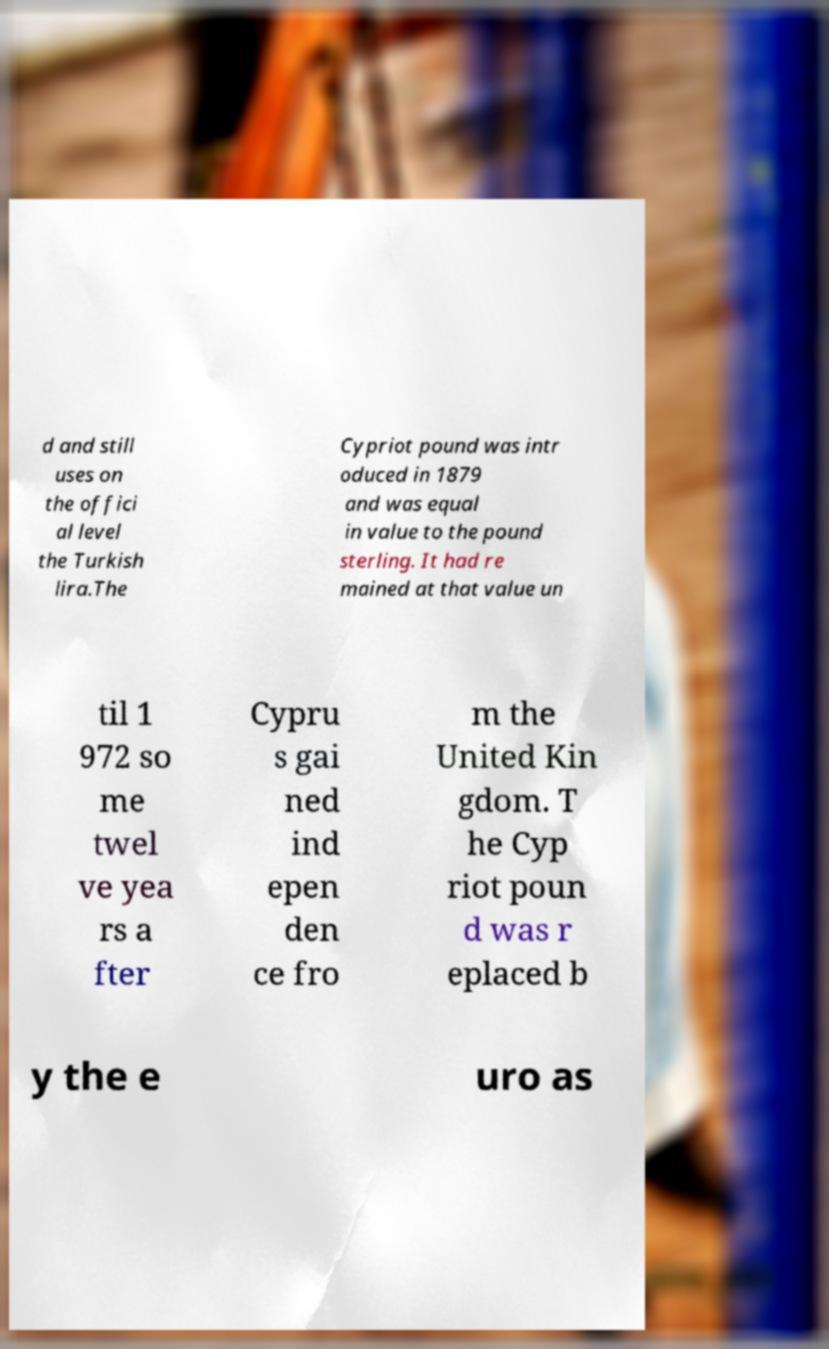What messages or text are displayed in this image? I need them in a readable, typed format. d and still uses on the offici al level the Turkish lira.The Cypriot pound was intr oduced in 1879 and was equal in value to the pound sterling. It had re mained at that value un til 1 972 so me twel ve yea rs a fter Cypru s gai ned ind epen den ce fro m the United Kin gdom. T he Cyp riot poun d was r eplaced b y the e uro as 